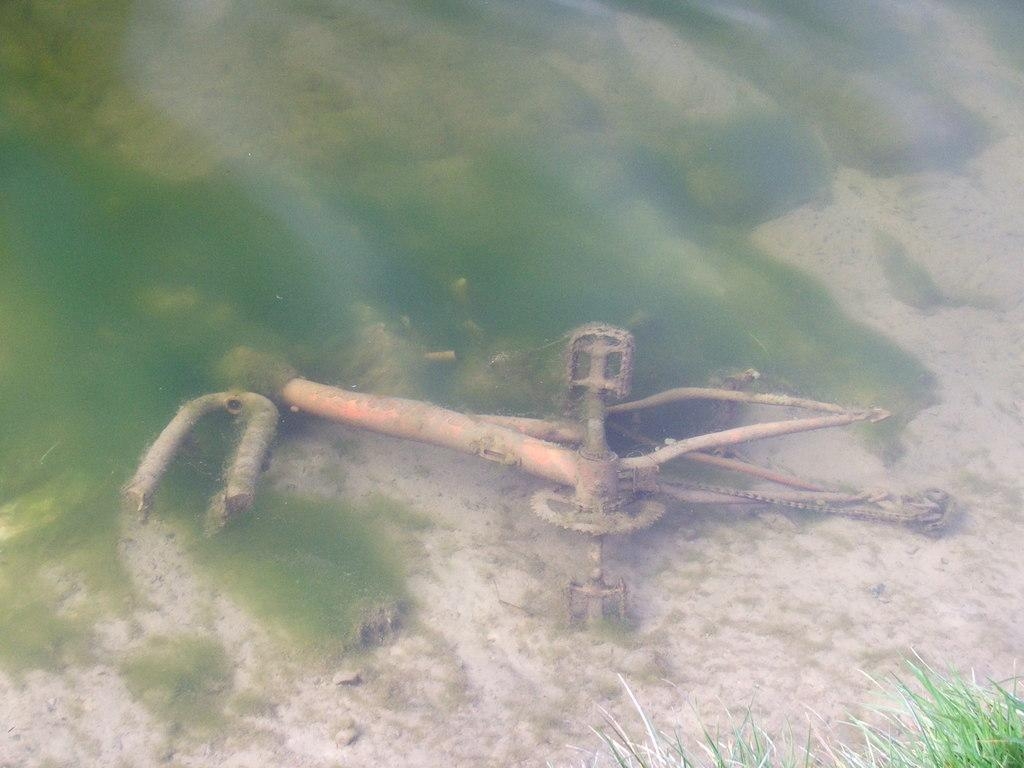What type of object is located in the foreground of the image? There is a metal object in the foreground of the image. What type of vegetation can be seen in the foreground of the image? There is grass in the foreground of the image. How many pizzas are visible on the bed in the image? There is no bed or pizzas present in the image; it only features a metal object and grass in the foreground. 